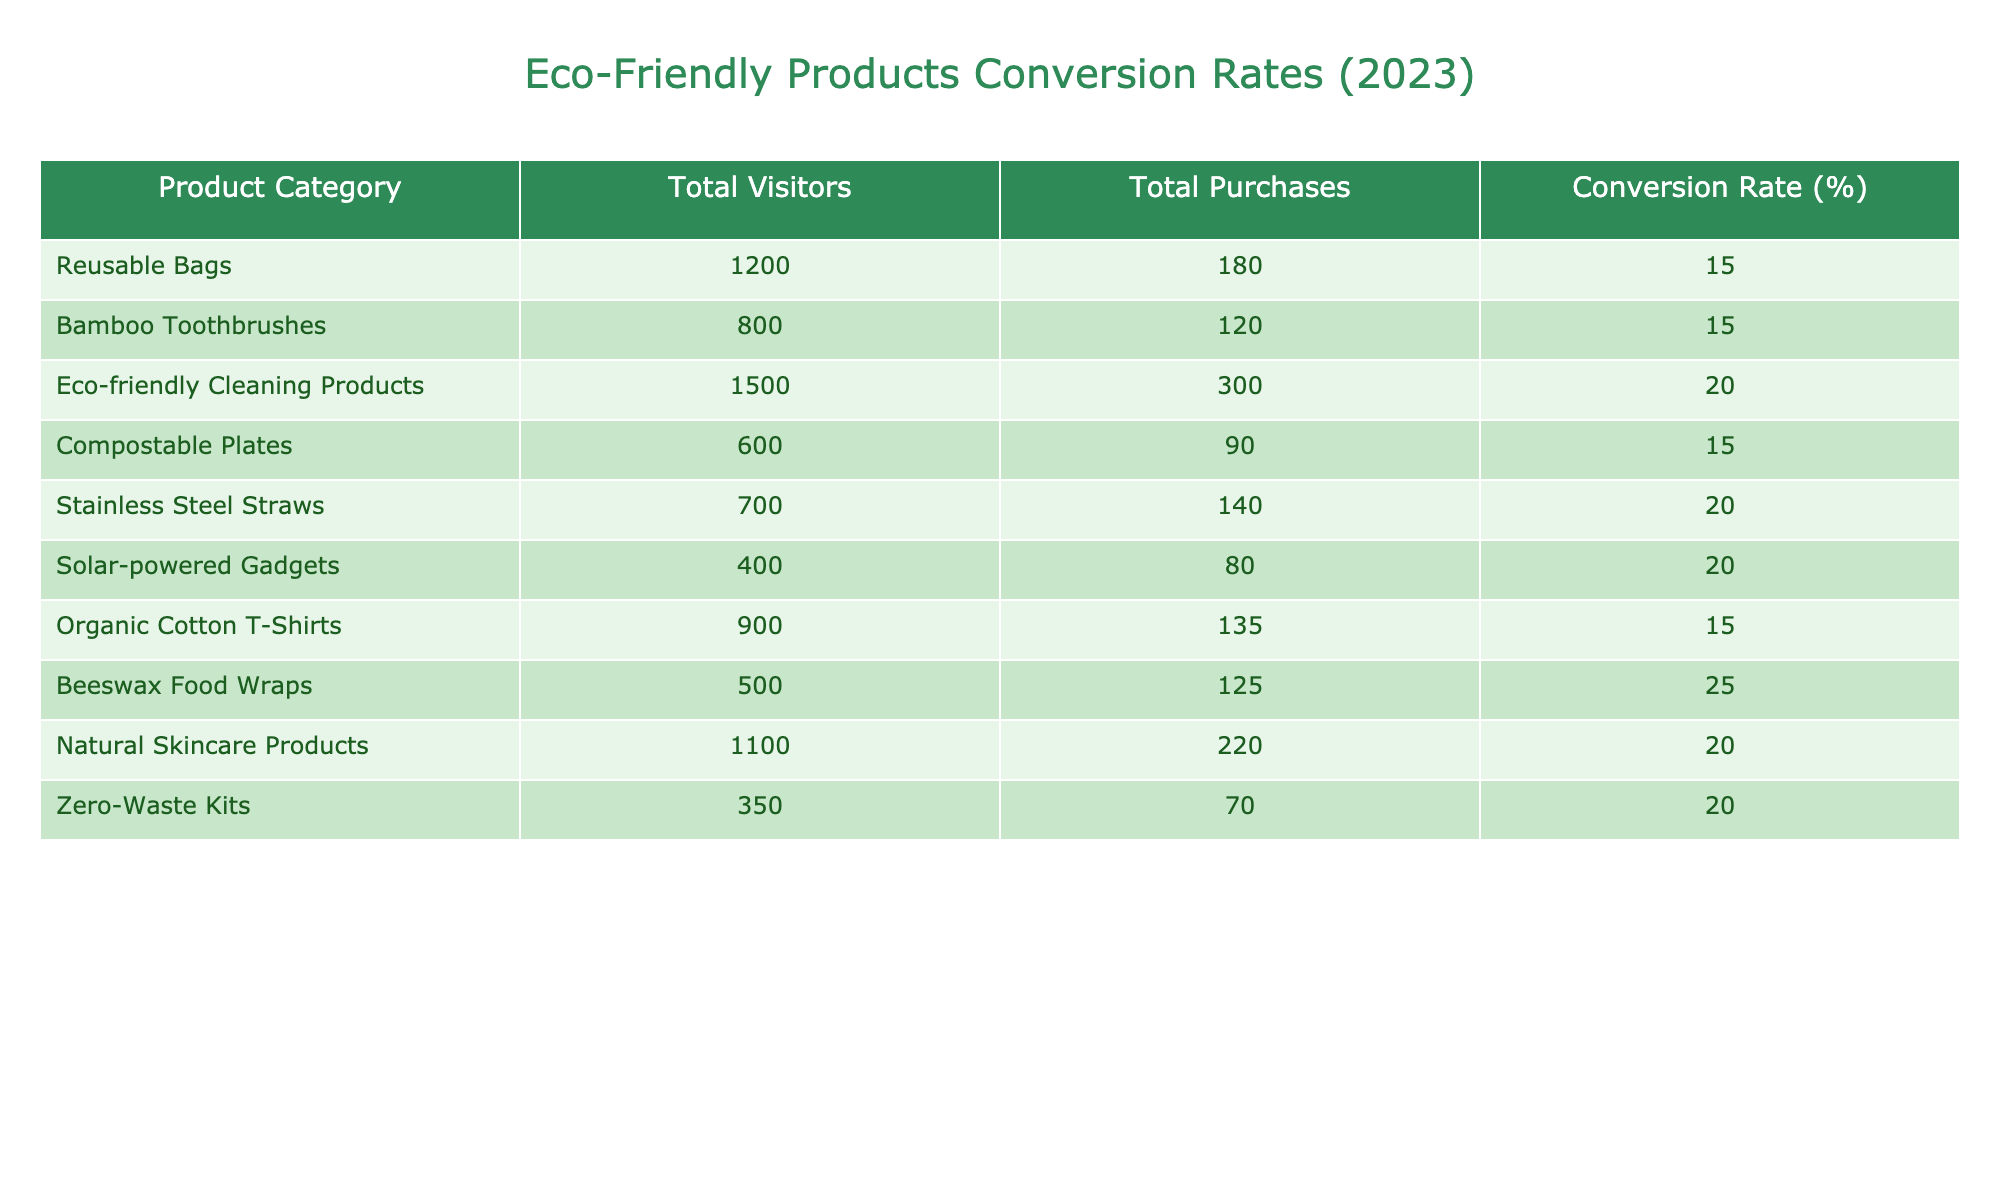What is the conversion rate for Beeswax Food Wraps? The conversion rate for Beeswax Food Wraps can be directly found in the table under the "Conversion Rate (%)" column for that product category, which is listed as 25%.
Answer: 25% Which product category has the highest conversion rate? By examining the "Conversion Rate (%)" column in the table, Beeswax Food Wraps has the highest conversion rate at 25%.
Answer: Beeswax Food Wraps How many total purchases were made for Eco-friendly Cleaning Products? The total purchases for Eco-friendly Cleaning Products is specified in the "Total Purchases" column as 300.
Answer: 300 What is the average conversion rate of all listed product categories? To calculate the average conversion rate, sum the conversion rates of all the product categories (15.0 + 15.0 + 20.0 + 15.0 + 20.0 + 20.0 + 15.0 + 25.0 + 20.0 + 20.0 = 200.0) and divide it by the total number of categories (10), which gives an average conversion rate of 20.0%.
Answer: 20.0% Is the conversion rate for Organic Cotton T-Shirts greater than 15%? By looking at the conversion rate listed for Organic Cotton T-Shirts in the table, which is 15%, we conclude that it is not greater than 15%.
Answer: No Which product category had the least number of total visitors? Comparing the "Total Visitors" across all product categories in the table, Zero-Waste Kits had the least number of total visitors, with only 350.
Answer: Zero-Waste Kits What is the difference in total purchases between Eco-friendly Cleaning Products and Bamboo Toothbrushes? Eco-friendly Cleaning Products had 300 total purchases and Bamboo Toothbrushes had 120. The difference can be calculated as 300 - 120 = 180.
Answer: 180 Do Stainless Steel Straws and Solar-powered Gadgets have the same conversion rate? By inspecting the "Conversion Rate (%)" column, both Stainless Steel Straws and Solar-powered Gadgets have a conversion rate of 20%. Thus, they do have the same conversion rate.
Answer: Yes Which product category has a conversion rate below the overall average? The overall average conversion rate is 20.0%. By checking the table, we see that Reusable Bags, Bamboo Toothbrushes, Compostable Plates, and Organic Cotton T-Shirts all have conversion rates of 15% which is below the average.
Answer: Reusable Bags, Bamboo Toothbrushes, Compostable Plates, Organic Cotton T-Shirts 